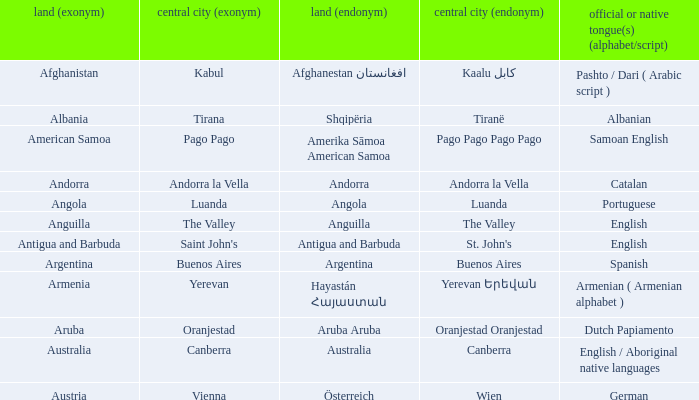What official or native languages are spoken in the country whose capital city is Canberra? English / Aboriginal native languages. 